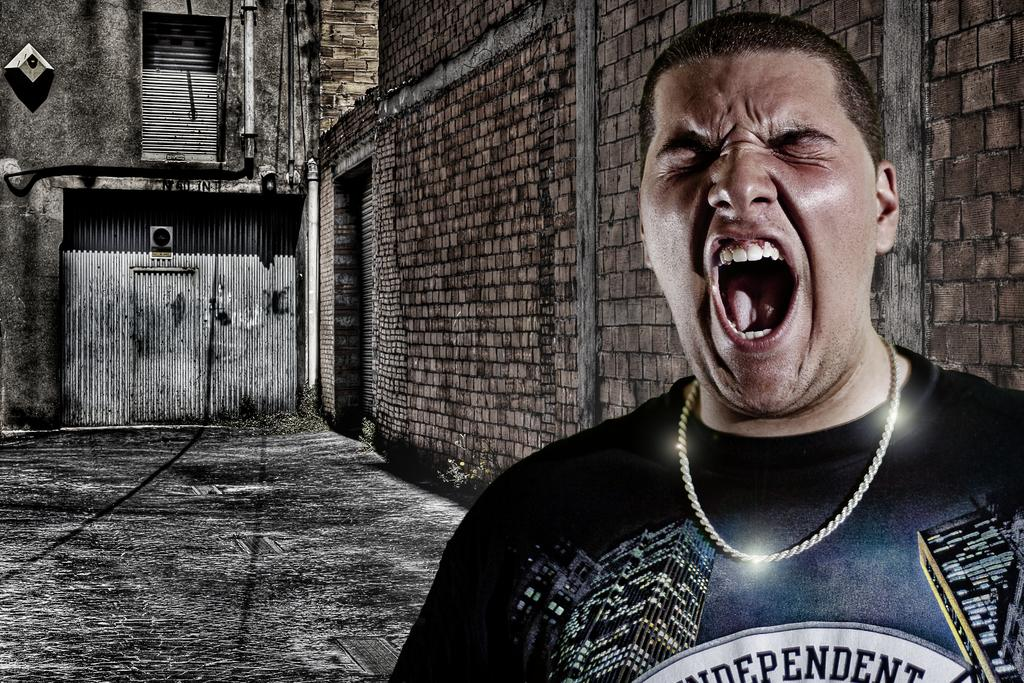What type of structure is visible in the image? There is a shed in the image. What are the boundaries of the shed made of? There are walls in the image. What can be seen running through the walls of the shed? There are pipelines in the image. Who is present in the shed in the image? There is a man standing on the floor in the image. What type of payment is being made in the image? There is no payment being made in the image; it only shows a shed with a man standing inside. 